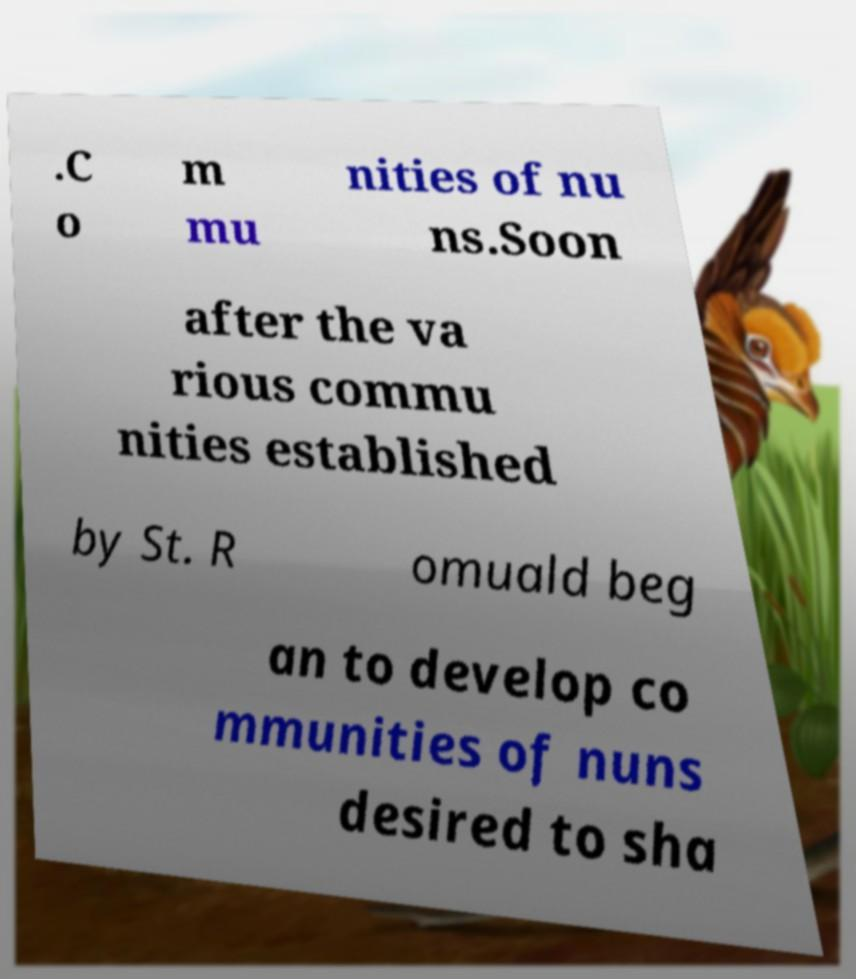Can you read and provide the text displayed in the image?This photo seems to have some interesting text. Can you extract and type it out for me? .C o m mu nities of nu ns.Soon after the va rious commu nities established by St. R omuald beg an to develop co mmunities of nuns desired to sha 